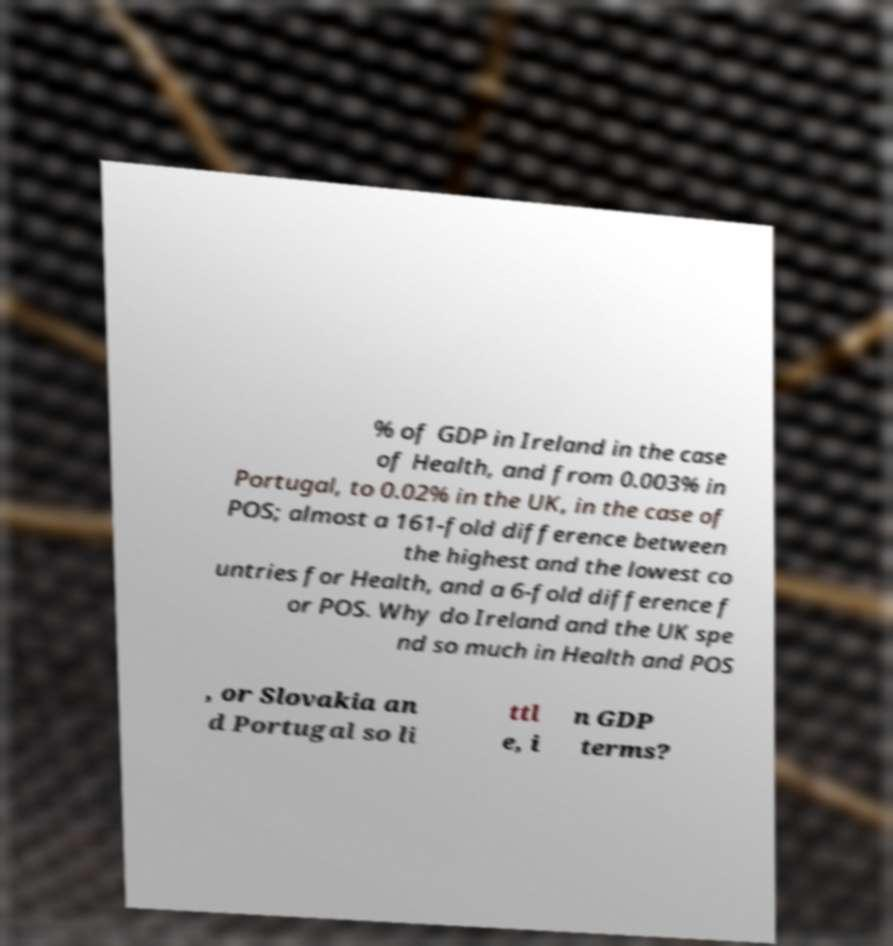There's text embedded in this image that I need extracted. Can you transcribe it verbatim? % of GDP in Ireland in the case of Health, and from 0.003% in Portugal, to 0.02% in the UK, in the case of POS; almost a 161-fold difference between the highest and the lowest co untries for Health, and a 6-fold difference f or POS. Why do Ireland and the UK spe nd so much in Health and POS , or Slovakia an d Portugal so li ttl e, i n GDP terms? 